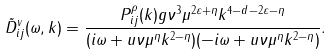Convert formula to latex. <formula><loc_0><loc_0><loc_500><loc_500>\tilde { D } _ { i j } ^ { v } ( \omega , k ) = \frac { P ^ { \rho } _ { i j } ( { k } ) g \nu ^ { 3 } \mu ^ { 2 \varepsilon + \eta } k ^ { 4 - d - 2 \varepsilon - \eta } } { ( i \omega + u \nu \mu ^ { \eta } k ^ { 2 - \eta } ) ( - i \omega + u \nu \mu ^ { \eta } k ^ { 2 - \eta } ) } .</formula> 